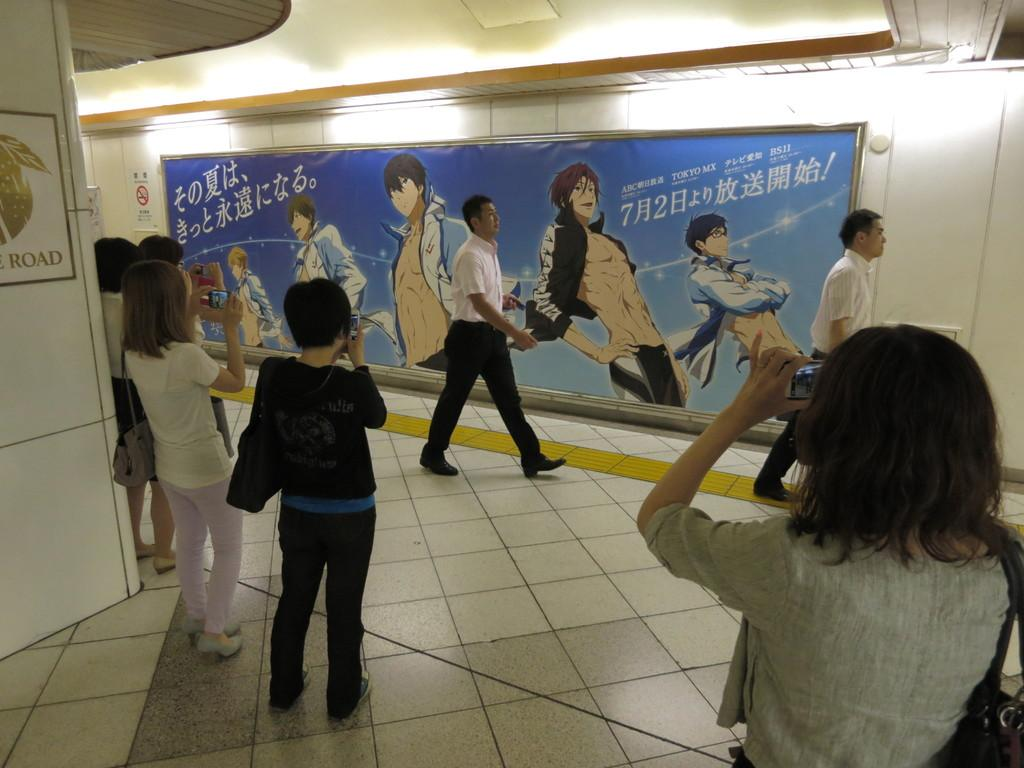What are the persons in the image doing? The persons in the image are taking pictures. What else can be seen in the image besides the persons taking pictures? Two persons are walking on a floor in the image. What is visible in the background of the image? There is a wall in the background of the image. Can you describe the wall in the background? There is a poster on the wall in the background. How long does it take for the oven to heat up in the image? There is no oven present in the image, so it is not possible to determine how long it takes for the oven to heat up. 